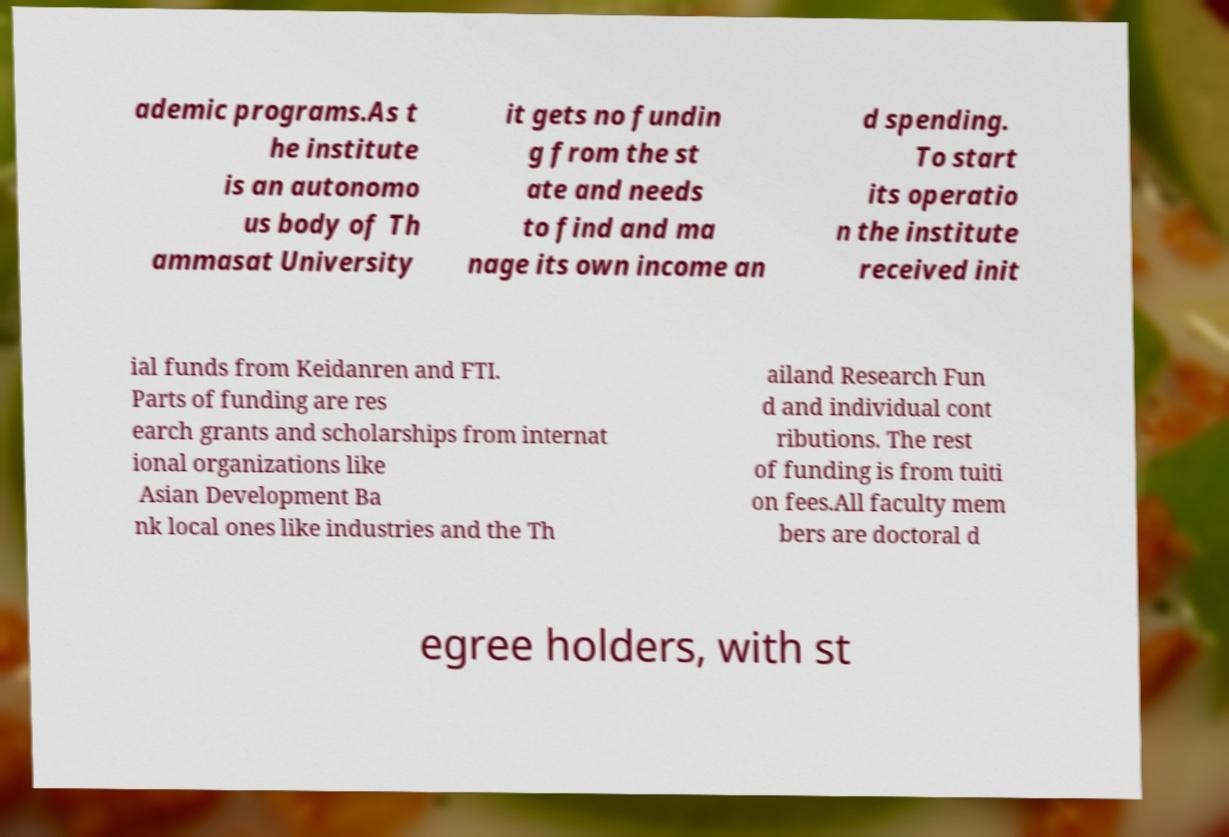For documentation purposes, I need the text within this image transcribed. Could you provide that? ademic programs.As t he institute is an autonomo us body of Th ammasat University it gets no fundin g from the st ate and needs to find and ma nage its own income an d spending. To start its operatio n the institute received init ial funds from Keidanren and FTI. Parts of funding are res earch grants and scholarships from internat ional organizations like Asian Development Ba nk local ones like industries and the Th ailand Research Fun d and individual cont ributions. The rest of funding is from tuiti on fees.All faculty mem bers are doctoral d egree holders, with st 